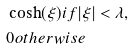Convert formula to latex. <formula><loc_0><loc_0><loc_500><loc_500>& \cosh ( \xi ) i f | \xi | < \lambda , \\ & 0 o t h e r w i s e</formula> 